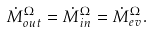<formula> <loc_0><loc_0><loc_500><loc_500>\dot { M } _ { o u t } ^ { \Omega } = \dot { M } _ { i n } ^ { \Omega } = \dot { M } _ { e v } ^ { \Omega } .</formula> 